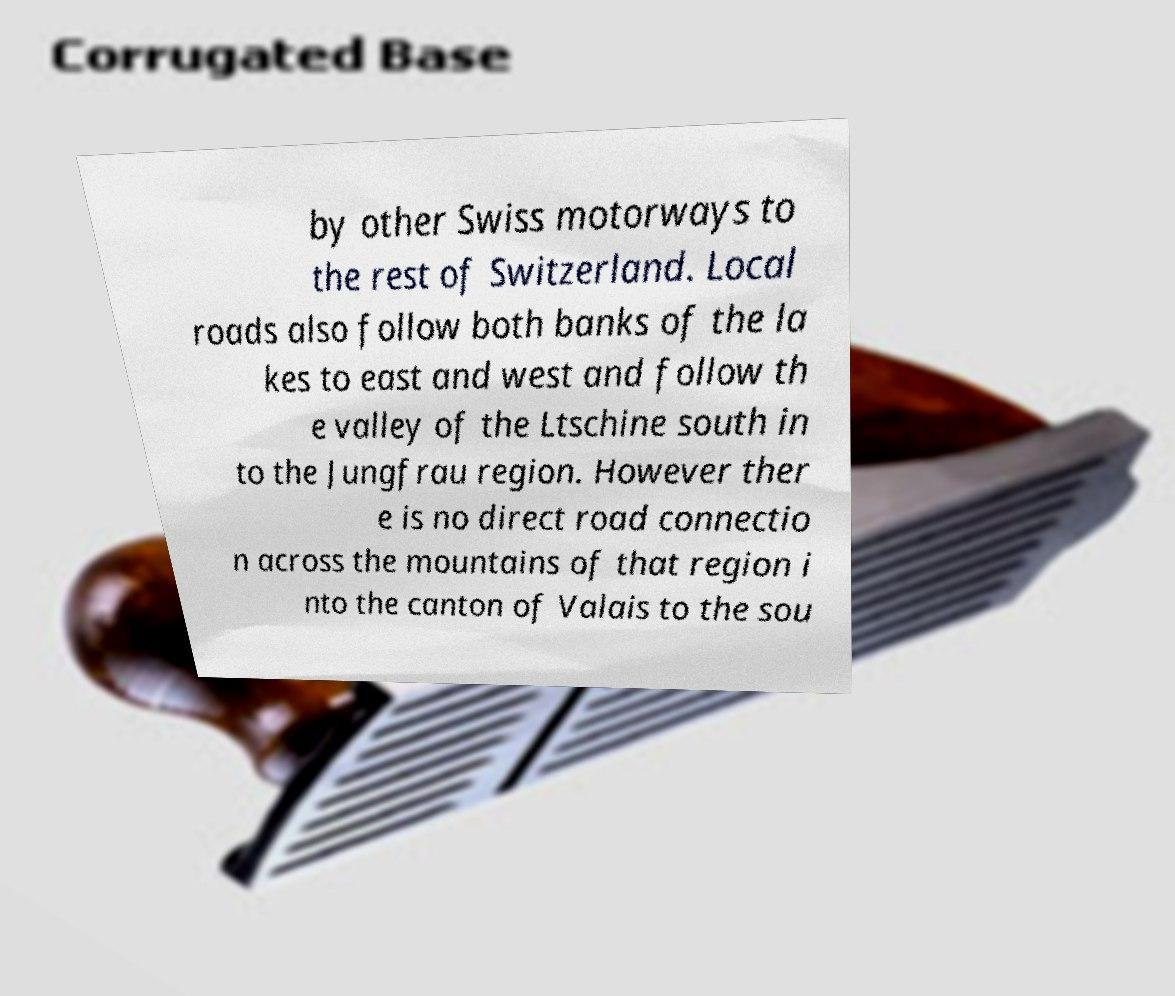Could you assist in decoding the text presented in this image and type it out clearly? by other Swiss motorways to the rest of Switzerland. Local roads also follow both banks of the la kes to east and west and follow th e valley of the Ltschine south in to the Jungfrau region. However ther e is no direct road connectio n across the mountains of that region i nto the canton of Valais to the sou 